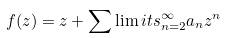Convert formula to latex. <formula><loc_0><loc_0><loc_500><loc_500>f ( z ) = z + \sum \lim i t s _ { n = 2 } ^ { \infty } a _ { n } z ^ { n }</formula> 